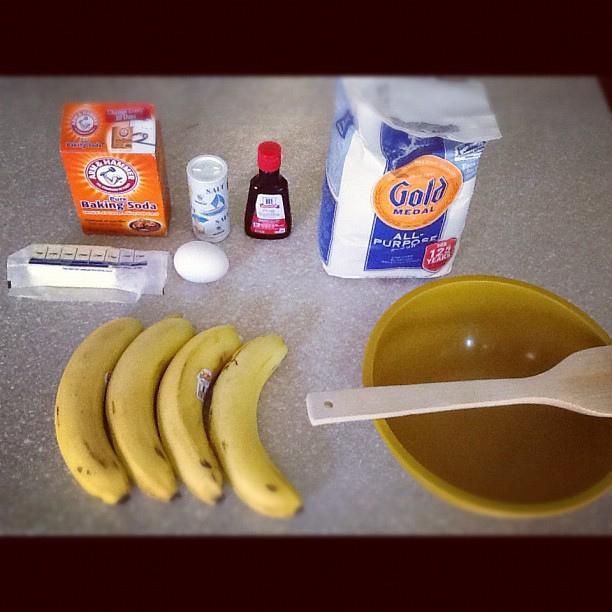How many bananas can be seen?
Give a very brief answer. 4. 